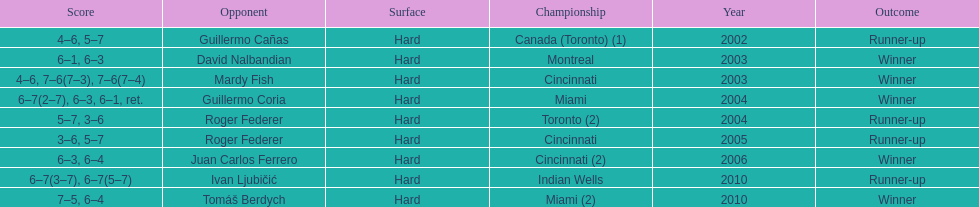I'm looking to parse the entire table for insights. Could you assist me with that? {'header': ['Score', 'Opponent', 'Surface', 'Championship', 'Year', 'Outcome'], 'rows': [['4–6, 5–7', 'Guillermo Cañas', 'Hard', 'Canada (Toronto) (1)', '2002', 'Runner-up'], ['6–1, 6–3', 'David Nalbandian', 'Hard', 'Montreal', '2003', 'Winner'], ['4–6, 7–6(7–3), 7–6(7–4)', 'Mardy Fish', 'Hard', 'Cincinnati', '2003', 'Winner'], ['6–7(2–7), 6–3, 6–1, ret.', 'Guillermo Coria', 'Hard', 'Miami', '2004', 'Winner'], ['5–7, 3–6', 'Roger Federer', 'Hard', 'Toronto (2)', '2004', 'Runner-up'], ['3–6, 5–7', 'Roger Federer', 'Hard', 'Cincinnati', '2005', 'Runner-up'], ['6–3, 6–4', 'Juan Carlos Ferrero', 'Hard', 'Cincinnati (2)', '2006', 'Winner'], ['6–7(3–7), 6–7(5–7)', 'Ivan Ljubičić', 'Hard', 'Indian Wells', '2010', 'Runner-up'], ['7–5, 6–4', 'Tomáš Berdych', 'Hard', 'Miami (2)', '2010', 'Winner']]} Was roddick a runner-up or winner more? Winner. 